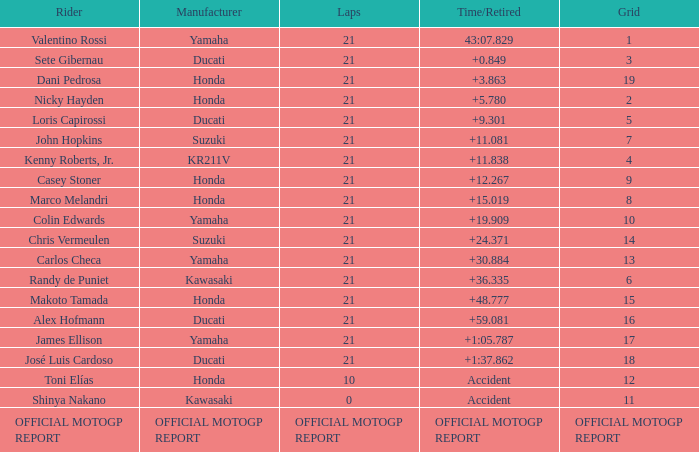At the point when john hopkins finished 21 laps, what was the grid's configuration? 7.0. 